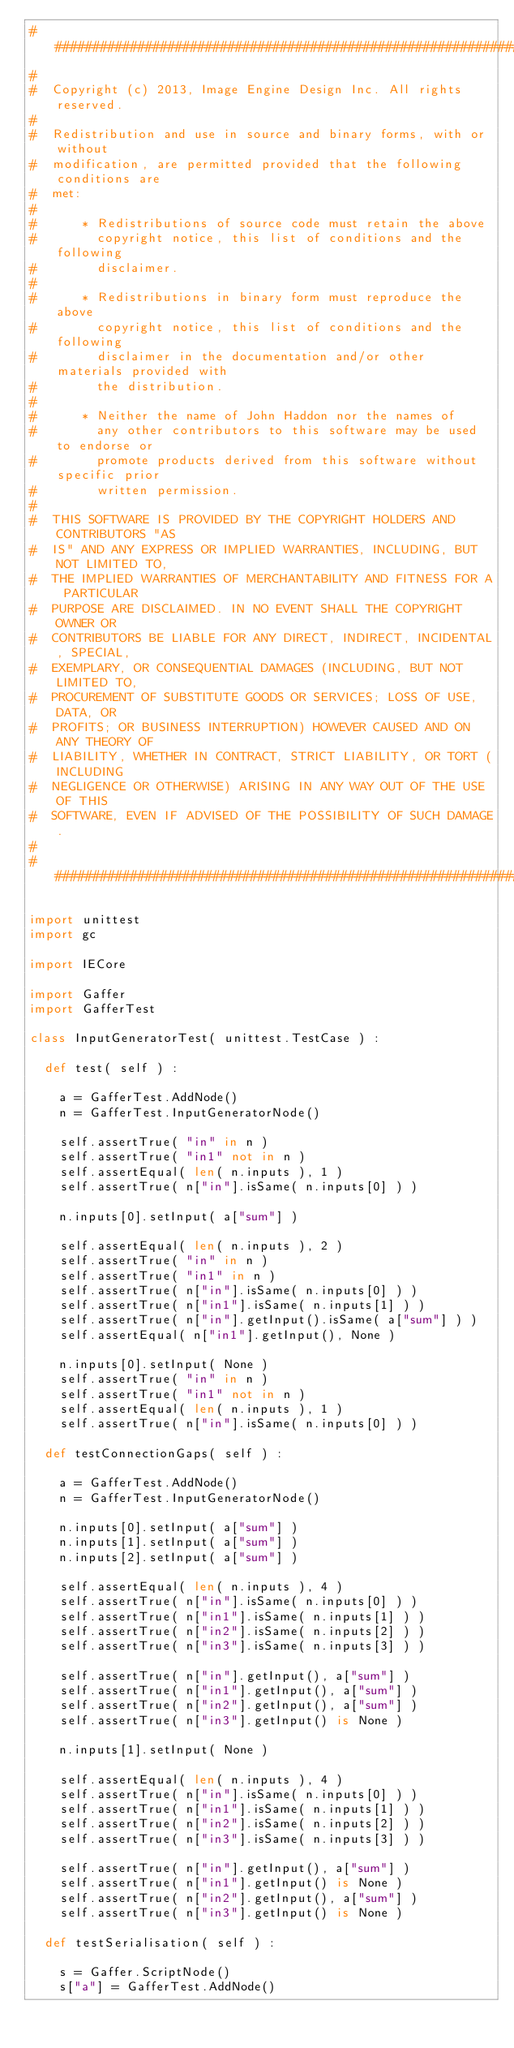Convert code to text. <code><loc_0><loc_0><loc_500><loc_500><_Python_>##########################################################################
#  
#  Copyright (c) 2013, Image Engine Design Inc. All rights reserved.
#  
#  Redistribution and use in source and binary forms, with or without
#  modification, are permitted provided that the following conditions are
#  met:
#  
#      * Redistributions of source code must retain the above
#        copyright notice, this list of conditions and the following
#        disclaimer.
#  
#      * Redistributions in binary form must reproduce the above
#        copyright notice, this list of conditions and the following
#        disclaimer in the documentation and/or other materials provided with
#        the distribution.
#  
#      * Neither the name of John Haddon nor the names of
#        any other contributors to this software may be used to endorse or
#        promote products derived from this software without specific prior
#        written permission.
#  
#  THIS SOFTWARE IS PROVIDED BY THE COPYRIGHT HOLDERS AND CONTRIBUTORS "AS
#  IS" AND ANY EXPRESS OR IMPLIED WARRANTIES, INCLUDING, BUT NOT LIMITED TO,
#  THE IMPLIED WARRANTIES OF MERCHANTABILITY AND FITNESS FOR A PARTICULAR
#  PURPOSE ARE DISCLAIMED. IN NO EVENT SHALL THE COPYRIGHT OWNER OR
#  CONTRIBUTORS BE LIABLE FOR ANY DIRECT, INDIRECT, INCIDENTAL, SPECIAL,
#  EXEMPLARY, OR CONSEQUENTIAL DAMAGES (INCLUDING, BUT NOT LIMITED TO,
#  PROCUREMENT OF SUBSTITUTE GOODS OR SERVICES; LOSS OF USE, DATA, OR
#  PROFITS; OR BUSINESS INTERRUPTION) HOWEVER CAUSED AND ON ANY THEORY OF
#  LIABILITY, WHETHER IN CONTRACT, STRICT LIABILITY, OR TORT (INCLUDING
#  NEGLIGENCE OR OTHERWISE) ARISING IN ANY WAY OUT OF THE USE OF THIS
#  SOFTWARE, EVEN IF ADVISED OF THE POSSIBILITY OF SUCH DAMAGE.
#  
##########################################################################

import unittest
import gc

import IECore

import Gaffer
import GafferTest

class InputGeneratorTest( unittest.TestCase ) :
		
	def test( self ) :

		a = GafferTest.AddNode()
		n = GafferTest.InputGeneratorNode()
		
		self.assertTrue( "in" in n )
		self.assertTrue( "in1" not in n )
		self.assertEqual( len( n.inputs ), 1 )
		self.assertTrue( n["in"].isSame( n.inputs[0] ) )

		n.inputs[0].setInput( a["sum"] )

		self.assertEqual( len( n.inputs ), 2 )
		self.assertTrue( "in" in n )
		self.assertTrue( "in1" in n )
		self.assertTrue( n["in"].isSame( n.inputs[0] ) )
		self.assertTrue( n["in1"].isSame( n.inputs[1] ) )
		self.assertTrue( n["in"].getInput().isSame( a["sum"] ) )
		self.assertEqual( n["in1"].getInput(), None )
		
		n.inputs[0].setInput( None )
		self.assertTrue( "in" in n )
		self.assertTrue( "in1" not in n )
		self.assertEqual( len( n.inputs ), 1 )
		self.assertTrue( n["in"].isSame( n.inputs[0] ) )
	
	def testConnectionGaps( self ) :
	
		a = GafferTest.AddNode()
		n = GafferTest.InputGeneratorNode()
		
		n.inputs[0].setInput( a["sum"] )
		n.inputs[1].setInput( a["sum"] )
		n.inputs[2].setInput( a["sum"] )
		
		self.assertEqual( len( n.inputs ), 4 )
		self.assertTrue( n["in"].isSame( n.inputs[0] ) )
		self.assertTrue( n["in1"].isSame( n.inputs[1] ) )
		self.assertTrue( n["in2"].isSame( n.inputs[2] ) )
		self.assertTrue( n["in3"].isSame( n.inputs[3] ) )
		
		self.assertTrue( n["in"].getInput(), a["sum"] )
		self.assertTrue( n["in1"].getInput(), a["sum"] )
		self.assertTrue( n["in2"].getInput(), a["sum"] )
		self.assertTrue( n["in3"].getInput() is None )
		
		n.inputs[1].setInput( None )
		
		self.assertEqual( len( n.inputs ), 4 )
		self.assertTrue( n["in"].isSame( n.inputs[0] ) )
		self.assertTrue( n["in1"].isSame( n.inputs[1] ) )
		self.assertTrue( n["in2"].isSame( n.inputs[2] ) )
		self.assertTrue( n["in3"].isSame( n.inputs[3] ) )
		
		self.assertTrue( n["in"].getInput(), a["sum"] )
		self.assertTrue( n["in1"].getInput() is None )
		self.assertTrue( n["in2"].getInput(), a["sum"] )
		self.assertTrue( n["in3"].getInput() is None )
	
	def testSerialisation( self ) :
	
		s = Gaffer.ScriptNode()
		s["a"] = GafferTest.AddNode()</code> 